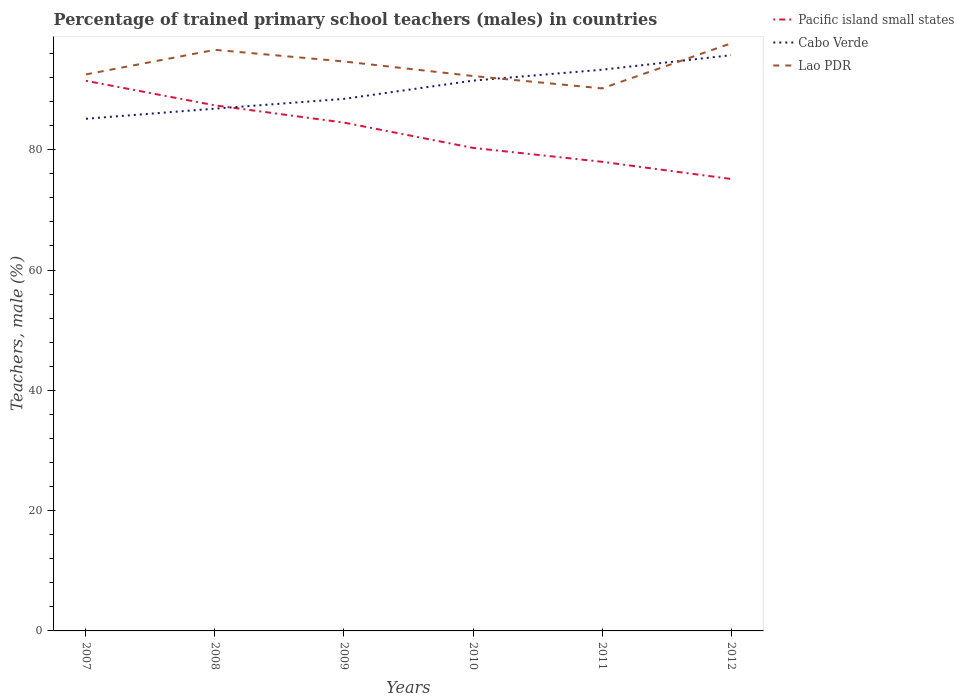How many different coloured lines are there?
Offer a very short reply. 3. Is the number of lines equal to the number of legend labels?
Provide a short and direct response. Yes. Across all years, what is the maximum percentage of trained primary school teachers (males) in Pacific island small states?
Keep it short and to the point. 75.14. In which year was the percentage of trained primary school teachers (males) in Pacific island small states maximum?
Offer a very short reply. 2012. What is the total percentage of trained primary school teachers (males) in Cabo Verde in the graph?
Ensure brevity in your answer.  -4.23. What is the difference between the highest and the second highest percentage of trained primary school teachers (males) in Pacific island small states?
Ensure brevity in your answer.  16.32. Does the graph contain grids?
Your response must be concise. No. Where does the legend appear in the graph?
Provide a short and direct response. Top right. What is the title of the graph?
Your answer should be compact. Percentage of trained primary school teachers (males) in countries. What is the label or title of the X-axis?
Keep it short and to the point. Years. What is the label or title of the Y-axis?
Your answer should be very brief. Teachers, male (%). What is the Teachers, male (%) of Pacific island small states in 2007?
Your answer should be very brief. 91.45. What is the Teachers, male (%) of Cabo Verde in 2007?
Provide a short and direct response. 85.15. What is the Teachers, male (%) in Lao PDR in 2007?
Offer a terse response. 92.52. What is the Teachers, male (%) of Pacific island small states in 2008?
Your answer should be very brief. 87.37. What is the Teachers, male (%) of Cabo Verde in 2008?
Provide a succinct answer. 86.83. What is the Teachers, male (%) in Lao PDR in 2008?
Keep it short and to the point. 96.61. What is the Teachers, male (%) in Pacific island small states in 2009?
Provide a succinct answer. 84.51. What is the Teachers, male (%) in Cabo Verde in 2009?
Your response must be concise. 88.45. What is the Teachers, male (%) of Lao PDR in 2009?
Your answer should be very brief. 94.67. What is the Teachers, male (%) in Pacific island small states in 2010?
Your answer should be very brief. 80.3. What is the Teachers, male (%) of Cabo Verde in 2010?
Your response must be concise. 91.49. What is the Teachers, male (%) of Lao PDR in 2010?
Provide a succinct answer. 92.25. What is the Teachers, male (%) of Pacific island small states in 2011?
Ensure brevity in your answer.  77.99. What is the Teachers, male (%) in Cabo Verde in 2011?
Your answer should be very brief. 93.3. What is the Teachers, male (%) of Lao PDR in 2011?
Your response must be concise. 90.19. What is the Teachers, male (%) in Pacific island small states in 2012?
Your response must be concise. 75.14. What is the Teachers, male (%) in Cabo Verde in 2012?
Keep it short and to the point. 95.71. What is the Teachers, male (%) of Lao PDR in 2012?
Offer a very short reply. 97.68. Across all years, what is the maximum Teachers, male (%) in Pacific island small states?
Ensure brevity in your answer.  91.45. Across all years, what is the maximum Teachers, male (%) in Cabo Verde?
Your answer should be compact. 95.71. Across all years, what is the maximum Teachers, male (%) of Lao PDR?
Keep it short and to the point. 97.68. Across all years, what is the minimum Teachers, male (%) in Pacific island small states?
Ensure brevity in your answer.  75.14. Across all years, what is the minimum Teachers, male (%) in Cabo Verde?
Your answer should be compact. 85.15. Across all years, what is the minimum Teachers, male (%) of Lao PDR?
Your response must be concise. 90.19. What is the total Teachers, male (%) in Pacific island small states in the graph?
Your answer should be compact. 496.77. What is the total Teachers, male (%) of Cabo Verde in the graph?
Your response must be concise. 540.93. What is the total Teachers, male (%) in Lao PDR in the graph?
Offer a terse response. 563.92. What is the difference between the Teachers, male (%) of Pacific island small states in 2007 and that in 2008?
Make the answer very short. 4.08. What is the difference between the Teachers, male (%) in Cabo Verde in 2007 and that in 2008?
Provide a short and direct response. -1.68. What is the difference between the Teachers, male (%) in Lao PDR in 2007 and that in 2008?
Offer a very short reply. -4.09. What is the difference between the Teachers, male (%) of Pacific island small states in 2007 and that in 2009?
Your response must be concise. 6.94. What is the difference between the Teachers, male (%) in Cabo Verde in 2007 and that in 2009?
Your answer should be very brief. -3.31. What is the difference between the Teachers, male (%) of Lao PDR in 2007 and that in 2009?
Provide a succinct answer. -2.15. What is the difference between the Teachers, male (%) of Pacific island small states in 2007 and that in 2010?
Provide a short and direct response. 11.15. What is the difference between the Teachers, male (%) in Cabo Verde in 2007 and that in 2010?
Your answer should be very brief. -6.34. What is the difference between the Teachers, male (%) in Lao PDR in 2007 and that in 2010?
Ensure brevity in your answer.  0.27. What is the difference between the Teachers, male (%) of Pacific island small states in 2007 and that in 2011?
Make the answer very short. 13.46. What is the difference between the Teachers, male (%) of Cabo Verde in 2007 and that in 2011?
Your answer should be very brief. -8.15. What is the difference between the Teachers, male (%) in Lao PDR in 2007 and that in 2011?
Offer a very short reply. 2.33. What is the difference between the Teachers, male (%) in Pacific island small states in 2007 and that in 2012?
Ensure brevity in your answer.  16.32. What is the difference between the Teachers, male (%) of Cabo Verde in 2007 and that in 2012?
Provide a succinct answer. -10.57. What is the difference between the Teachers, male (%) of Lao PDR in 2007 and that in 2012?
Keep it short and to the point. -5.16. What is the difference between the Teachers, male (%) in Pacific island small states in 2008 and that in 2009?
Offer a terse response. 2.86. What is the difference between the Teachers, male (%) of Cabo Verde in 2008 and that in 2009?
Provide a succinct answer. -1.62. What is the difference between the Teachers, male (%) of Lao PDR in 2008 and that in 2009?
Your response must be concise. 1.94. What is the difference between the Teachers, male (%) in Pacific island small states in 2008 and that in 2010?
Offer a very short reply. 7.07. What is the difference between the Teachers, male (%) in Cabo Verde in 2008 and that in 2010?
Your answer should be very brief. -4.66. What is the difference between the Teachers, male (%) of Lao PDR in 2008 and that in 2010?
Give a very brief answer. 4.35. What is the difference between the Teachers, male (%) in Pacific island small states in 2008 and that in 2011?
Your answer should be very brief. 9.38. What is the difference between the Teachers, male (%) of Cabo Verde in 2008 and that in 2011?
Your answer should be very brief. -6.47. What is the difference between the Teachers, male (%) of Lao PDR in 2008 and that in 2011?
Your answer should be very brief. 6.41. What is the difference between the Teachers, male (%) in Pacific island small states in 2008 and that in 2012?
Offer a very short reply. 12.24. What is the difference between the Teachers, male (%) in Cabo Verde in 2008 and that in 2012?
Your response must be concise. -8.88. What is the difference between the Teachers, male (%) of Lao PDR in 2008 and that in 2012?
Provide a short and direct response. -1.08. What is the difference between the Teachers, male (%) of Pacific island small states in 2009 and that in 2010?
Your answer should be compact. 4.21. What is the difference between the Teachers, male (%) of Cabo Verde in 2009 and that in 2010?
Your answer should be compact. -3.03. What is the difference between the Teachers, male (%) of Lao PDR in 2009 and that in 2010?
Your answer should be very brief. 2.42. What is the difference between the Teachers, male (%) of Pacific island small states in 2009 and that in 2011?
Your answer should be very brief. 6.52. What is the difference between the Teachers, male (%) in Cabo Verde in 2009 and that in 2011?
Keep it short and to the point. -4.85. What is the difference between the Teachers, male (%) in Lao PDR in 2009 and that in 2011?
Offer a terse response. 4.48. What is the difference between the Teachers, male (%) in Pacific island small states in 2009 and that in 2012?
Your response must be concise. 9.37. What is the difference between the Teachers, male (%) in Cabo Verde in 2009 and that in 2012?
Your answer should be compact. -7.26. What is the difference between the Teachers, male (%) in Lao PDR in 2009 and that in 2012?
Your answer should be very brief. -3.01. What is the difference between the Teachers, male (%) of Pacific island small states in 2010 and that in 2011?
Your response must be concise. 2.31. What is the difference between the Teachers, male (%) of Cabo Verde in 2010 and that in 2011?
Your answer should be compact. -1.81. What is the difference between the Teachers, male (%) in Lao PDR in 2010 and that in 2011?
Make the answer very short. 2.06. What is the difference between the Teachers, male (%) in Pacific island small states in 2010 and that in 2012?
Your answer should be compact. 5.17. What is the difference between the Teachers, male (%) of Cabo Verde in 2010 and that in 2012?
Provide a succinct answer. -4.23. What is the difference between the Teachers, male (%) in Lao PDR in 2010 and that in 2012?
Your response must be concise. -5.43. What is the difference between the Teachers, male (%) in Pacific island small states in 2011 and that in 2012?
Give a very brief answer. 2.86. What is the difference between the Teachers, male (%) in Cabo Verde in 2011 and that in 2012?
Your answer should be compact. -2.41. What is the difference between the Teachers, male (%) of Lao PDR in 2011 and that in 2012?
Offer a terse response. -7.49. What is the difference between the Teachers, male (%) of Pacific island small states in 2007 and the Teachers, male (%) of Cabo Verde in 2008?
Keep it short and to the point. 4.62. What is the difference between the Teachers, male (%) of Pacific island small states in 2007 and the Teachers, male (%) of Lao PDR in 2008?
Your answer should be very brief. -5.15. What is the difference between the Teachers, male (%) of Cabo Verde in 2007 and the Teachers, male (%) of Lao PDR in 2008?
Make the answer very short. -11.46. What is the difference between the Teachers, male (%) of Pacific island small states in 2007 and the Teachers, male (%) of Cabo Verde in 2009?
Offer a very short reply. 3. What is the difference between the Teachers, male (%) in Pacific island small states in 2007 and the Teachers, male (%) in Lao PDR in 2009?
Make the answer very short. -3.22. What is the difference between the Teachers, male (%) of Cabo Verde in 2007 and the Teachers, male (%) of Lao PDR in 2009?
Make the answer very short. -9.52. What is the difference between the Teachers, male (%) of Pacific island small states in 2007 and the Teachers, male (%) of Cabo Verde in 2010?
Provide a short and direct response. -0.03. What is the difference between the Teachers, male (%) in Pacific island small states in 2007 and the Teachers, male (%) in Lao PDR in 2010?
Your answer should be compact. -0.8. What is the difference between the Teachers, male (%) in Cabo Verde in 2007 and the Teachers, male (%) in Lao PDR in 2010?
Offer a very short reply. -7.11. What is the difference between the Teachers, male (%) in Pacific island small states in 2007 and the Teachers, male (%) in Cabo Verde in 2011?
Offer a terse response. -1.85. What is the difference between the Teachers, male (%) of Pacific island small states in 2007 and the Teachers, male (%) of Lao PDR in 2011?
Provide a short and direct response. 1.26. What is the difference between the Teachers, male (%) of Cabo Verde in 2007 and the Teachers, male (%) of Lao PDR in 2011?
Provide a short and direct response. -5.05. What is the difference between the Teachers, male (%) in Pacific island small states in 2007 and the Teachers, male (%) in Cabo Verde in 2012?
Provide a succinct answer. -4.26. What is the difference between the Teachers, male (%) of Pacific island small states in 2007 and the Teachers, male (%) of Lao PDR in 2012?
Give a very brief answer. -6.23. What is the difference between the Teachers, male (%) of Cabo Verde in 2007 and the Teachers, male (%) of Lao PDR in 2012?
Provide a short and direct response. -12.54. What is the difference between the Teachers, male (%) in Pacific island small states in 2008 and the Teachers, male (%) in Cabo Verde in 2009?
Provide a succinct answer. -1.08. What is the difference between the Teachers, male (%) in Pacific island small states in 2008 and the Teachers, male (%) in Lao PDR in 2009?
Offer a very short reply. -7.3. What is the difference between the Teachers, male (%) in Cabo Verde in 2008 and the Teachers, male (%) in Lao PDR in 2009?
Your answer should be very brief. -7.84. What is the difference between the Teachers, male (%) of Pacific island small states in 2008 and the Teachers, male (%) of Cabo Verde in 2010?
Provide a succinct answer. -4.11. What is the difference between the Teachers, male (%) in Pacific island small states in 2008 and the Teachers, male (%) in Lao PDR in 2010?
Your response must be concise. -4.88. What is the difference between the Teachers, male (%) in Cabo Verde in 2008 and the Teachers, male (%) in Lao PDR in 2010?
Make the answer very short. -5.42. What is the difference between the Teachers, male (%) in Pacific island small states in 2008 and the Teachers, male (%) in Cabo Verde in 2011?
Your answer should be compact. -5.93. What is the difference between the Teachers, male (%) of Pacific island small states in 2008 and the Teachers, male (%) of Lao PDR in 2011?
Give a very brief answer. -2.82. What is the difference between the Teachers, male (%) in Cabo Verde in 2008 and the Teachers, male (%) in Lao PDR in 2011?
Provide a short and direct response. -3.36. What is the difference between the Teachers, male (%) of Pacific island small states in 2008 and the Teachers, male (%) of Cabo Verde in 2012?
Your answer should be compact. -8.34. What is the difference between the Teachers, male (%) of Pacific island small states in 2008 and the Teachers, male (%) of Lao PDR in 2012?
Your answer should be very brief. -10.31. What is the difference between the Teachers, male (%) of Cabo Verde in 2008 and the Teachers, male (%) of Lao PDR in 2012?
Give a very brief answer. -10.85. What is the difference between the Teachers, male (%) of Pacific island small states in 2009 and the Teachers, male (%) of Cabo Verde in 2010?
Provide a succinct answer. -6.97. What is the difference between the Teachers, male (%) in Pacific island small states in 2009 and the Teachers, male (%) in Lao PDR in 2010?
Provide a succinct answer. -7.74. What is the difference between the Teachers, male (%) in Cabo Verde in 2009 and the Teachers, male (%) in Lao PDR in 2010?
Offer a very short reply. -3.8. What is the difference between the Teachers, male (%) in Pacific island small states in 2009 and the Teachers, male (%) in Cabo Verde in 2011?
Keep it short and to the point. -8.79. What is the difference between the Teachers, male (%) in Pacific island small states in 2009 and the Teachers, male (%) in Lao PDR in 2011?
Your answer should be very brief. -5.68. What is the difference between the Teachers, male (%) in Cabo Verde in 2009 and the Teachers, male (%) in Lao PDR in 2011?
Your response must be concise. -1.74. What is the difference between the Teachers, male (%) in Pacific island small states in 2009 and the Teachers, male (%) in Cabo Verde in 2012?
Make the answer very short. -11.2. What is the difference between the Teachers, male (%) in Pacific island small states in 2009 and the Teachers, male (%) in Lao PDR in 2012?
Give a very brief answer. -13.17. What is the difference between the Teachers, male (%) of Cabo Verde in 2009 and the Teachers, male (%) of Lao PDR in 2012?
Ensure brevity in your answer.  -9.23. What is the difference between the Teachers, male (%) of Pacific island small states in 2010 and the Teachers, male (%) of Cabo Verde in 2011?
Offer a very short reply. -13. What is the difference between the Teachers, male (%) in Pacific island small states in 2010 and the Teachers, male (%) in Lao PDR in 2011?
Offer a terse response. -9.89. What is the difference between the Teachers, male (%) in Cabo Verde in 2010 and the Teachers, male (%) in Lao PDR in 2011?
Your response must be concise. 1.29. What is the difference between the Teachers, male (%) in Pacific island small states in 2010 and the Teachers, male (%) in Cabo Verde in 2012?
Keep it short and to the point. -15.41. What is the difference between the Teachers, male (%) of Pacific island small states in 2010 and the Teachers, male (%) of Lao PDR in 2012?
Make the answer very short. -17.38. What is the difference between the Teachers, male (%) in Cabo Verde in 2010 and the Teachers, male (%) in Lao PDR in 2012?
Your response must be concise. -6.2. What is the difference between the Teachers, male (%) of Pacific island small states in 2011 and the Teachers, male (%) of Cabo Verde in 2012?
Offer a terse response. -17.72. What is the difference between the Teachers, male (%) of Pacific island small states in 2011 and the Teachers, male (%) of Lao PDR in 2012?
Your answer should be compact. -19.69. What is the difference between the Teachers, male (%) in Cabo Verde in 2011 and the Teachers, male (%) in Lao PDR in 2012?
Your response must be concise. -4.38. What is the average Teachers, male (%) in Pacific island small states per year?
Make the answer very short. 82.8. What is the average Teachers, male (%) of Cabo Verde per year?
Give a very brief answer. 90.15. What is the average Teachers, male (%) of Lao PDR per year?
Offer a very short reply. 93.99. In the year 2007, what is the difference between the Teachers, male (%) in Pacific island small states and Teachers, male (%) in Cabo Verde?
Your answer should be very brief. 6.31. In the year 2007, what is the difference between the Teachers, male (%) in Pacific island small states and Teachers, male (%) in Lao PDR?
Your answer should be very brief. -1.07. In the year 2007, what is the difference between the Teachers, male (%) of Cabo Verde and Teachers, male (%) of Lao PDR?
Offer a very short reply. -7.37. In the year 2008, what is the difference between the Teachers, male (%) of Pacific island small states and Teachers, male (%) of Cabo Verde?
Make the answer very short. 0.55. In the year 2008, what is the difference between the Teachers, male (%) of Pacific island small states and Teachers, male (%) of Lao PDR?
Ensure brevity in your answer.  -9.23. In the year 2008, what is the difference between the Teachers, male (%) of Cabo Verde and Teachers, male (%) of Lao PDR?
Provide a short and direct response. -9.78. In the year 2009, what is the difference between the Teachers, male (%) of Pacific island small states and Teachers, male (%) of Cabo Verde?
Keep it short and to the point. -3.94. In the year 2009, what is the difference between the Teachers, male (%) in Pacific island small states and Teachers, male (%) in Lao PDR?
Your answer should be very brief. -10.16. In the year 2009, what is the difference between the Teachers, male (%) of Cabo Verde and Teachers, male (%) of Lao PDR?
Ensure brevity in your answer.  -6.22. In the year 2010, what is the difference between the Teachers, male (%) of Pacific island small states and Teachers, male (%) of Cabo Verde?
Give a very brief answer. -11.18. In the year 2010, what is the difference between the Teachers, male (%) in Pacific island small states and Teachers, male (%) in Lao PDR?
Provide a short and direct response. -11.95. In the year 2010, what is the difference between the Teachers, male (%) of Cabo Verde and Teachers, male (%) of Lao PDR?
Keep it short and to the point. -0.77. In the year 2011, what is the difference between the Teachers, male (%) in Pacific island small states and Teachers, male (%) in Cabo Verde?
Offer a terse response. -15.31. In the year 2011, what is the difference between the Teachers, male (%) in Pacific island small states and Teachers, male (%) in Lao PDR?
Offer a terse response. -12.2. In the year 2011, what is the difference between the Teachers, male (%) of Cabo Verde and Teachers, male (%) of Lao PDR?
Provide a succinct answer. 3.11. In the year 2012, what is the difference between the Teachers, male (%) of Pacific island small states and Teachers, male (%) of Cabo Verde?
Make the answer very short. -20.58. In the year 2012, what is the difference between the Teachers, male (%) of Pacific island small states and Teachers, male (%) of Lao PDR?
Provide a succinct answer. -22.55. In the year 2012, what is the difference between the Teachers, male (%) in Cabo Verde and Teachers, male (%) in Lao PDR?
Your answer should be very brief. -1.97. What is the ratio of the Teachers, male (%) of Pacific island small states in 2007 to that in 2008?
Provide a short and direct response. 1.05. What is the ratio of the Teachers, male (%) in Cabo Verde in 2007 to that in 2008?
Provide a short and direct response. 0.98. What is the ratio of the Teachers, male (%) of Lao PDR in 2007 to that in 2008?
Provide a short and direct response. 0.96. What is the ratio of the Teachers, male (%) of Pacific island small states in 2007 to that in 2009?
Make the answer very short. 1.08. What is the ratio of the Teachers, male (%) of Cabo Verde in 2007 to that in 2009?
Your answer should be very brief. 0.96. What is the ratio of the Teachers, male (%) of Lao PDR in 2007 to that in 2009?
Your response must be concise. 0.98. What is the ratio of the Teachers, male (%) in Pacific island small states in 2007 to that in 2010?
Your response must be concise. 1.14. What is the ratio of the Teachers, male (%) in Cabo Verde in 2007 to that in 2010?
Your response must be concise. 0.93. What is the ratio of the Teachers, male (%) in Pacific island small states in 2007 to that in 2011?
Give a very brief answer. 1.17. What is the ratio of the Teachers, male (%) in Cabo Verde in 2007 to that in 2011?
Your answer should be very brief. 0.91. What is the ratio of the Teachers, male (%) of Lao PDR in 2007 to that in 2011?
Your answer should be very brief. 1.03. What is the ratio of the Teachers, male (%) in Pacific island small states in 2007 to that in 2012?
Make the answer very short. 1.22. What is the ratio of the Teachers, male (%) in Cabo Verde in 2007 to that in 2012?
Give a very brief answer. 0.89. What is the ratio of the Teachers, male (%) in Lao PDR in 2007 to that in 2012?
Make the answer very short. 0.95. What is the ratio of the Teachers, male (%) of Pacific island small states in 2008 to that in 2009?
Offer a very short reply. 1.03. What is the ratio of the Teachers, male (%) of Cabo Verde in 2008 to that in 2009?
Your response must be concise. 0.98. What is the ratio of the Teachers, male (%) in Lao PDR in 2008 to that in 2009?
Ensure brevity in your answer.  1.02. What is the ratio of the Teachers, male (%) in Pacific island small states in 2008 to that in 2010?
Offer a terse response. 1.09. What is the ratio of the Teachers, male (%) of Cabo Verde in 2008 to that in 2010?
Make the answer very short. 0.95. What is the ratio of the Teachers, male (%) of Lao PDR in 2008 to that in 2010?
Your answer should be very brief. 1.05. What is the ratio of the Teachers, male (%) in Pacific island small states in 2008 to that in 2011?
Ensure brevity in your answer.  1.12. What is the ratio of the Teachers, male (%) in Cabo Verde in 2008 to that in 2011?
Offer a very short reply. 0.93. What is the ratio of the Teachers, male (%) in Lao PDR in 2008 to that in 2011?
Offer a terse response. 1.07. What is the ratio of the Teachers, male (%) in Pacific island small states in 2008 to that in 2012?
Provide a succinct answer. 1.16. What is the ratio of the Teachers, male (%) in Cabo Verde in 2008 to that in 2012?
Offer a terse response. 0.91. What is the ratio of the Teachers, male (%) in Lao PDR in 2008 to that in 2012?
Your answer should be very brief. 0.99. What is the ratio of the Teachers, male (%) of Pacific island small states in 2009 to that in 2010?
Your answer should be very brief. 1.05. What is the ratio of the Teachers, male (%) of Cabo Verde in 2009 to that in 2010?
Offer a terse response. 0.97. What is the ratio of the Teachers, male (%) of Lao PDR in 2009 to that in 2010?
Your response must be concise. 1.03. What is the ratio of the Teachers, male (%) in Pacific island small states in 2009 to that in 2011?
Offer a very short reply. 1.08. What is the ratio of the Teachers, male (%) of Cabo Verde in 2009 to that in 2011?
Make the answer very short. 0.95. What is the ratio of the Teachers, male (%) of Lao PDR in 2009 to that in 2011?
Offer a terse response. 1.05. What is the ratio of the Teachers, male (%) of Pacific island small states in 2009 to that in 2012?
Ensure brevity in your answer.  1.12. What is the ratio of the Teachers, male (%) of Cabo Verde in 2009 to that in 2012?
Your response must be concise. 0.92. What is the ratio of the Teachers, male (%) of Lao PDR in 2009 to that in 2012?
Your response must be concise. 0.97. What is the ratio of the Teachers, male (%) in Pacific island small states in 2010 to that in 2011?
Give a very brief answer. 1.03. What is the ratio of the Teachers, male (%) of Cabo Verde in 2010 to that in 2011?
Give a very brief answer. 0.98. What is the ratio of the Teachers, male (%) of Lao PDR in 2010 to that in 2011?
Provide a short and direct response. 1.02. What is the ratio of the Teachers, male (%) in Pacific island small states in 2010 to that in 2012?
Provide a short and direct response. 1.07. What is the ratio of the Teachers, male (%) of Cabo Verde in 2010 to that in 2012?
Keep it short and to the point. 0.96. What is the ratio of the Teachers, male (%) of Lao PDR in 2010 to that in 2012?
Make the answer very short. 0.94. What is the ratio of the Teachers, male (%) of Pacific island small states in 2011 to that in 2012?
Provide a short and direct response. 1.04. What is the ratio of the Teachers, male (%) of Cabo Verde in 2011 to that in 2012?
Offer a very short reply. 0.97. What is the ratio of the Teachers, male (%) in Lao PDR in 2011 to that in 2012?
Offer a terse response. 0.92. What is the difference between the highest and the second highest Teachers, male (%) of Pacific island small states?
Your response must be concise. 4.08. What is the difference between the highest and the second highest Teachers, male (%) in Cabo Verde?
Your answer should be compact. 2.41. What is the difference between the highest and the second highest Teachers, male (%) of Lao PDR?
Keep it short and to the point. 1.08. What is the difference between the highest and the lowest Teachers, male (%) of Pacific island small states?
Provide a succinct answer. 16.32. What is the difference between the highest and the lowest Teachers, male (%) in Cabo Verde?
Ensure brevity in your answer.  10.57. What is the difference between the highest and the lowest Teachers, male (%) in Lao PDR?
Ensure brevity in your answer.  7.49. 